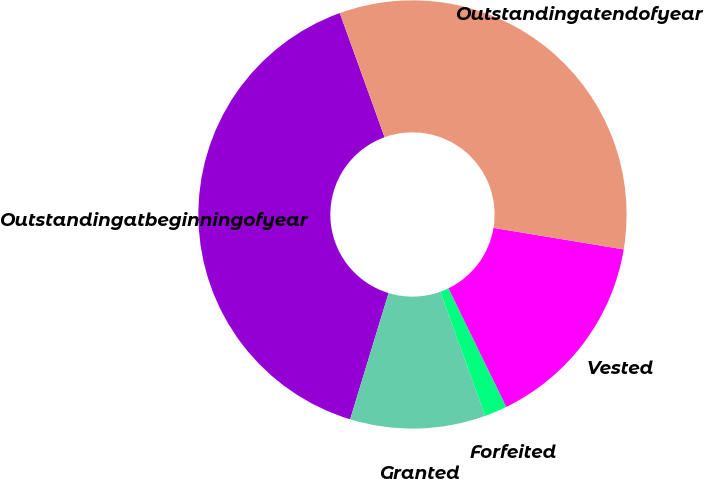Convert chart to OTSL. <chart><loc_0><loc_0><loc_500><loc_500><pie_chart><fcel>Outstandingatbeginningofyear<fcel>Granted<fcel>Forfeited<fcel>Vested<fcel>Outstandingatendofyear<nl><fcel>39.79%<fcel>10.21%<fcel>1.71%<fcel>15.17%<fcel>33.12%<nl></chart> 